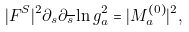Convert formula to latex. <formula><loc_0><loc_0><loc_500><loc_500>| F ^ { S } | ^ { 2 } \partial _ { s } \partial _ { \overline { s } } \ln g _ { a } ^ { 2 } = | M _ { a } ^ { ( 0 ) } | ^ { 2 } ,</formula> 